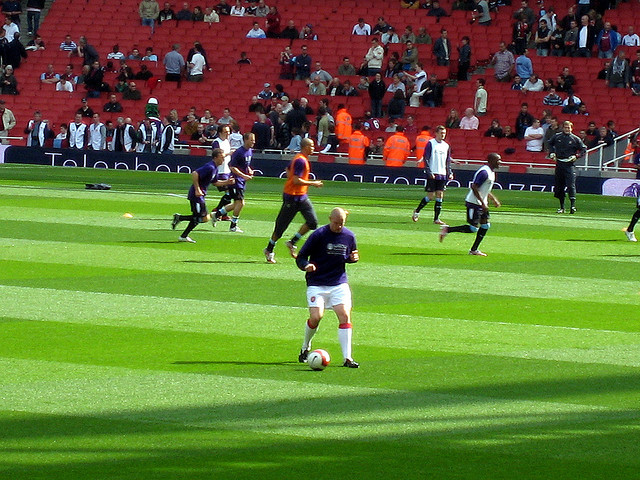Please transcribe the text in this image. 6 